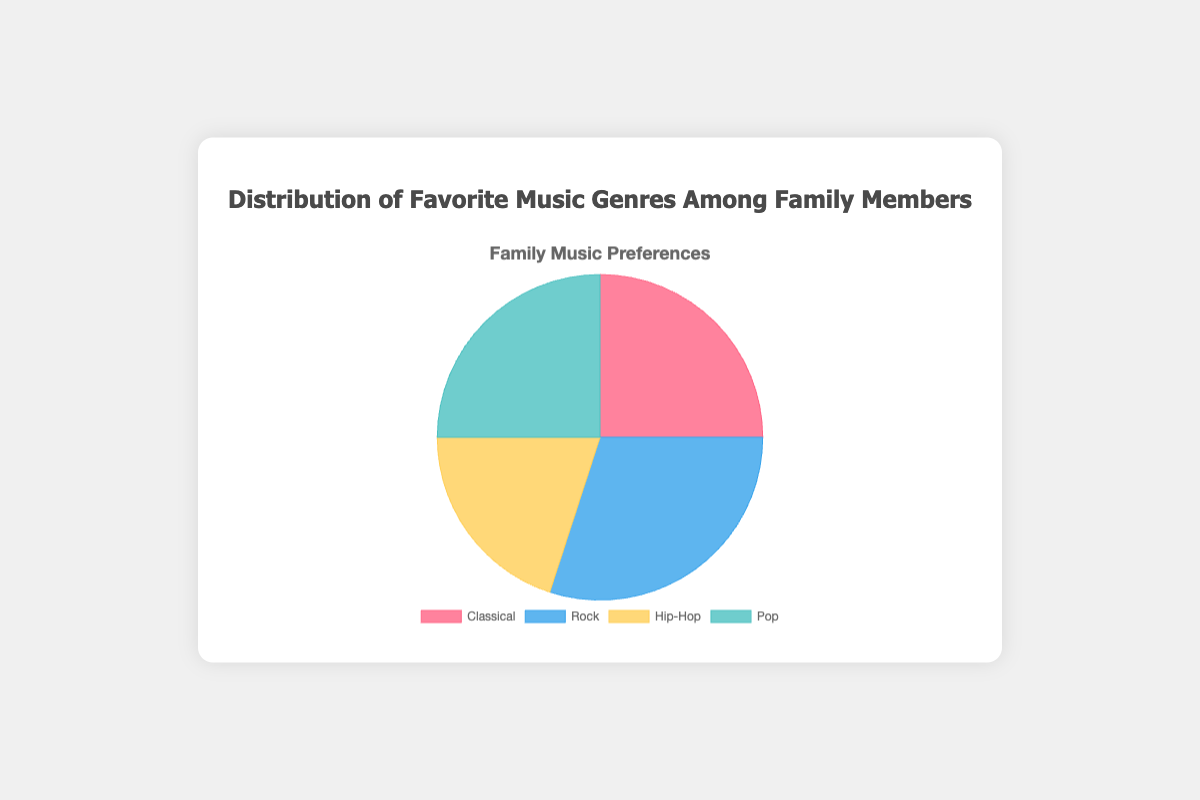What's the most popular music genre among family members? The pie chart shows the largest portion of the distribution is Rock, represented by 30%.
Answer: Rock What percentage of the family's favorite music genres is shared by both parent and youngest child? The parent and youngest child like Classical and Pop respectively. Summing up their percentages, we get 25% + 25% = 50%.
Answer: 50% Which music genre is more popular: Classical or Hip-Hop? By comparing the percentages, Classical has 25% while Hip-Hop has 20%. Classical has a higher percentage.
Answer: Classical What two genres together make up half of the family's music preferences? Adding the percentages for Classical (25%) and Pop (25%), we get 25% + 25% = 50%.
Answer: Classical and Pop Is the combined percentage of Middle and Youngest Child's favorite genres greater than that of the Parent and Eldest Child? Middle Child's Hip-Hop is 20% and Youngest Child's Pop is 25%, adding up to 45%. Parent's Classical is 25% and Eldest Child's Rock is 30%, adding up to 55%. So, 45% is less than 55%.
Answer: No Describe the color used for the genre that has a 20% share in the pie chart. The pie chart uses specific colors to represent each genre. The 20% share represents Hip-Hop, which is colored yellow.
Answer: Yellow Which genres have exactly the same percentage share in the family's favorite music genres? By observing the percentages, Classical and Pop both have a 25% share.
Answer: Classical and Pop Between Rock and Pop, which genre is less popular? Rock has a 30% share, whereas Pop has a 25% share. Since 25% is less than 30%, Pop is less popular.
Answer: Pop What is the average percentage of family members' favorite music genres across the four categories? Sum up the percentages: 25% (Classical) + 30% (Rock) + 20% (Hip-Hop) + 25% (Pop) = 100%. The average percentage is 100% / 4 = 25%.
Answer: 25% 